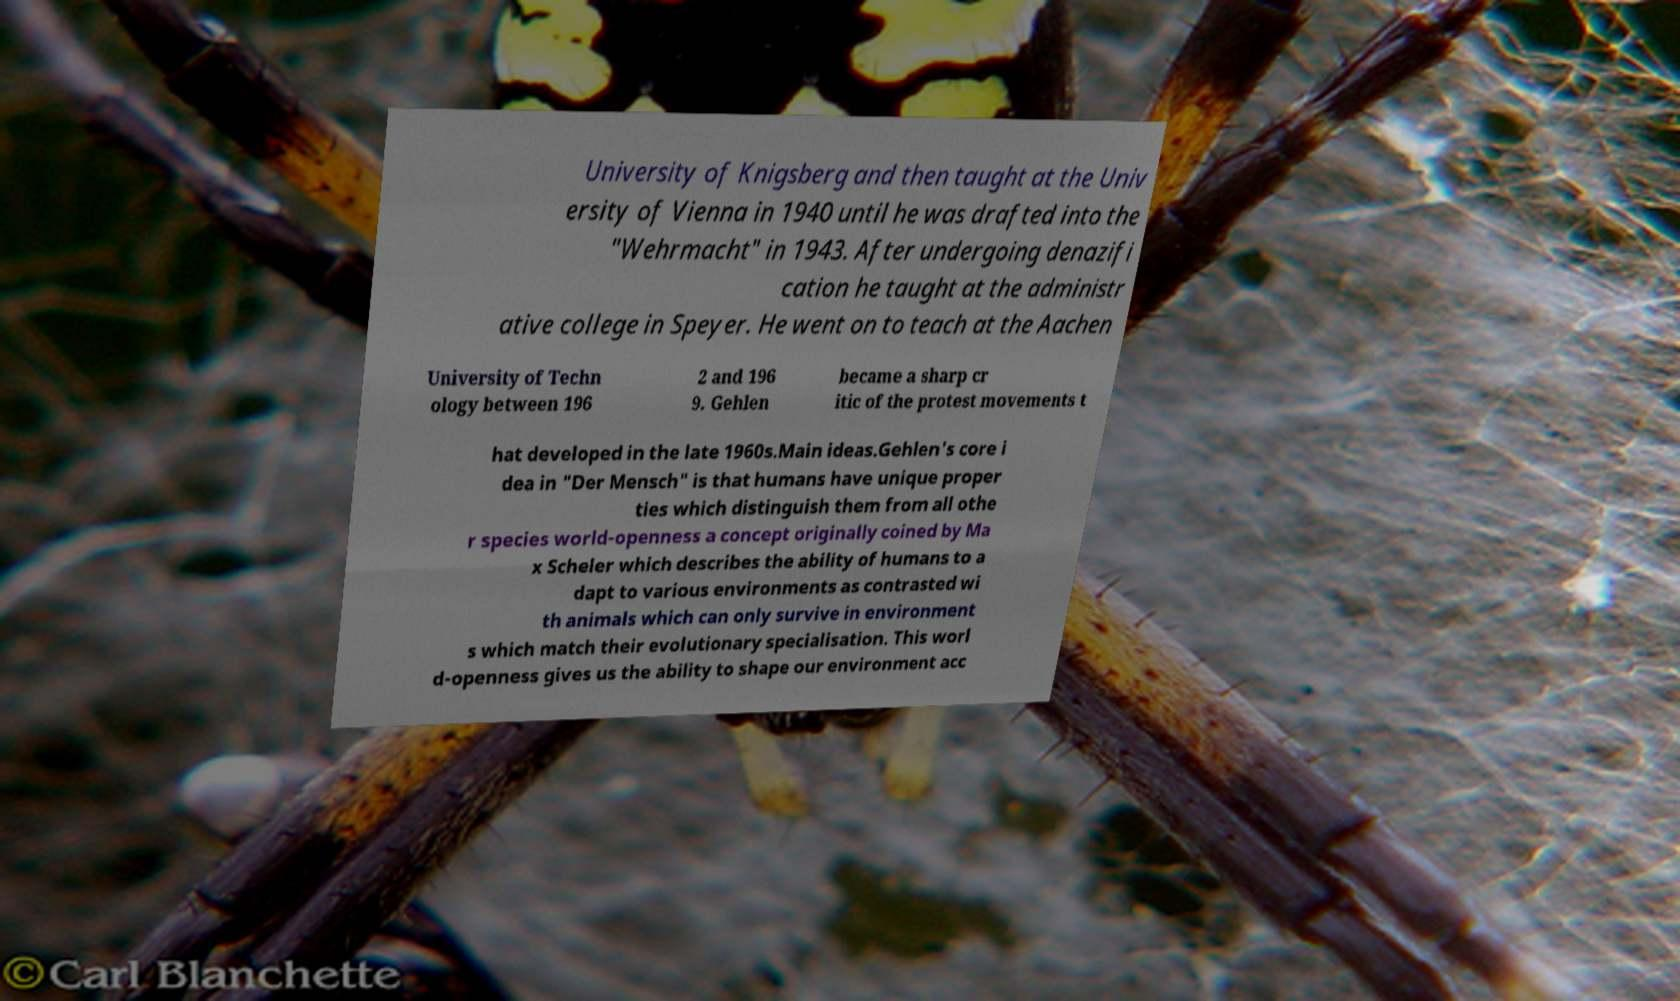I need the written content from this picture converted into text. Can you do that? University of Knigsberg and then taught at the Univ ersity of Vienna in 1940 until he was drafted into the "Wehrmacht" in 1943. After undergoing denazifi cation he taught at the administr ative college in Speyer. He went on to teach at the Aachen University of Techn ology between 196 2 and 196 9. Gehlen became a sharp cr itic of the protest movements t hat developed in the late 1960s.Main ideas.Gehlen's core i dea in "Der Mensch" is that humans have unique proper ties which distinguish them from all othe r species world-openness a concept originally coined by Ma x Scheler which describes the ability of humans to a dapt to various environments as contrasted wi th animals which can only survive in environment s which match their evolutionary specialisation. This worl d-openness gives us the ability to shape our environment acc 